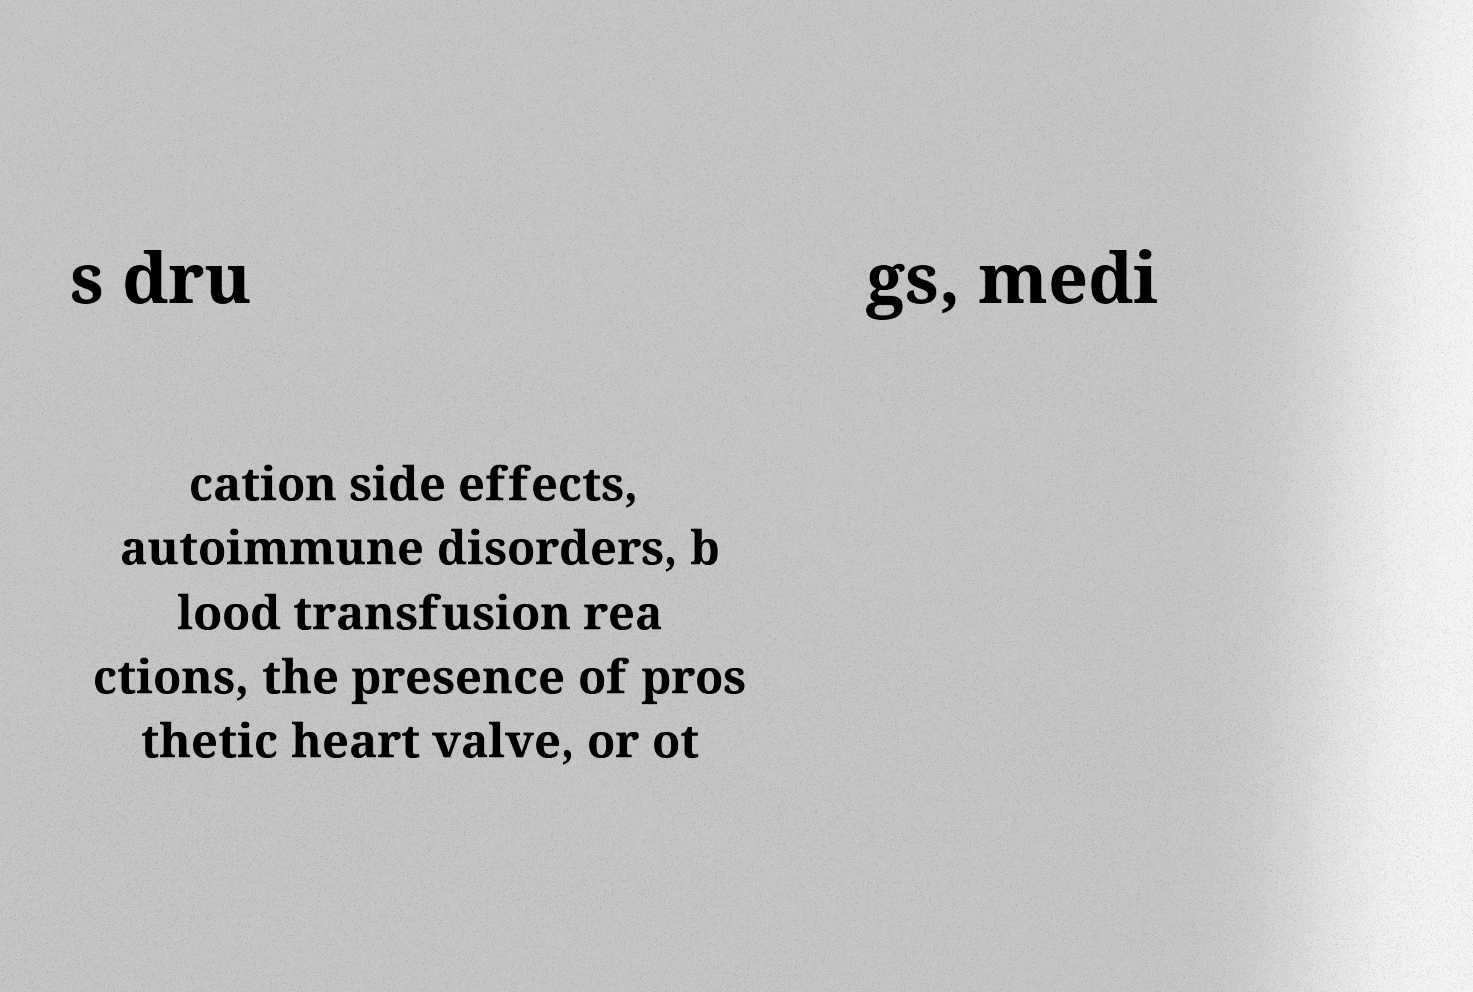There's text embedded in this image that I need extracted. Can you transcribe it verbatim? s dru gs, medi cation side effects, autoimmune disorders, b lood transfusion rea ctions, the presence of pros thetic heart valve, or ot 